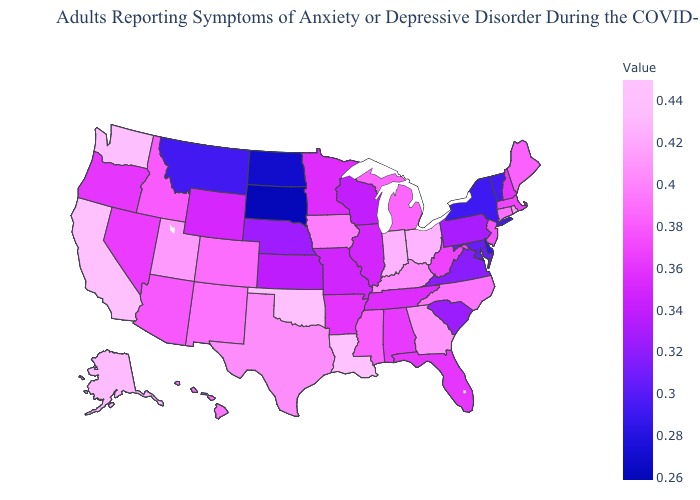Among the states that border New Hampshire , does Vermont have the lowest value?
Be succinct. Yes. Does Massachusetts have the lowest value in the USA?
Short answer required. No. Among the states that border Illinois , does Wisconsin have the lowest value?
Answer briefly. Yes. Which states hav the highest value in the MidWest?
Give a very brief answer. Ohio. Among the states that border California , which have the lowest value?
Quick response, please. Oregon. Does the map have missing data?
Quick response, please. No. Is the legend a continuous bar?
Answer briefly. Yes. Among the states that border South Carolina , which have the lowest value?
Write a very short answer. North Carolina. 